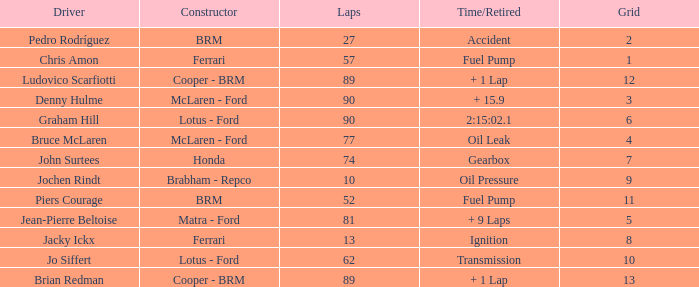I'm looking to parse the entire table for insights. Could you assist me with that? {'header': ['Driver', 'Constructor', 'Laps', 'Time/Retired', 'Grid'], 'rows': [['Pedro Rodríguez', 'BRM', '27', 'Accident', '2'], ['Chris Amon', 'Ferrari', '57', 'Fuel Pump', '1'], ['Ludovico Scarfiotti', 'Cooper - BRM', '89', '+ 1 Lap', '12'], ['Denny Hulme', 'McLaren - Ford', '90', '+ 15.9', '3'], ['Graham Hill', 'Lotus - Ford', '90', '2:15:02.1', '6'], ['Bruce McLaren', 'McLaren - Ford', '77', 'Oil Leak', '4'], ['John Surtees', 'Honda', '74', 'Gearbox', '7'], ['Jochen Rindt', 'Brabham - Repco', '10', 'Oil Pressure', '9'], ['Piers Courage', 'BRM', '52', 'Fuel Pump', '11'], ['Jean-Pierre Beltoise', 'Matra - Ford', '81', '+ 9 Laps', '5'], ['Jacky Ickx', 'Ferrari', '13', 'Ignition', '8'], ['Jo Siffert', 'Lotus - Ford', '62', 'Transmission', '10'], ['Brian Redman', 'Cooper - BRM', '89', '+ 1 Lap', '13']]} What is the time/retired when the laps is 52? Fuel Pump. 